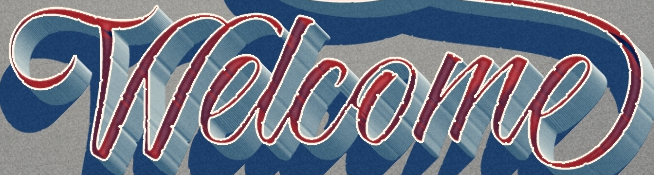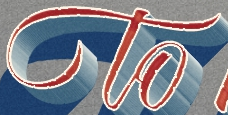Read the text from these images in sequence, separated by a semicolon. Welcome; to 